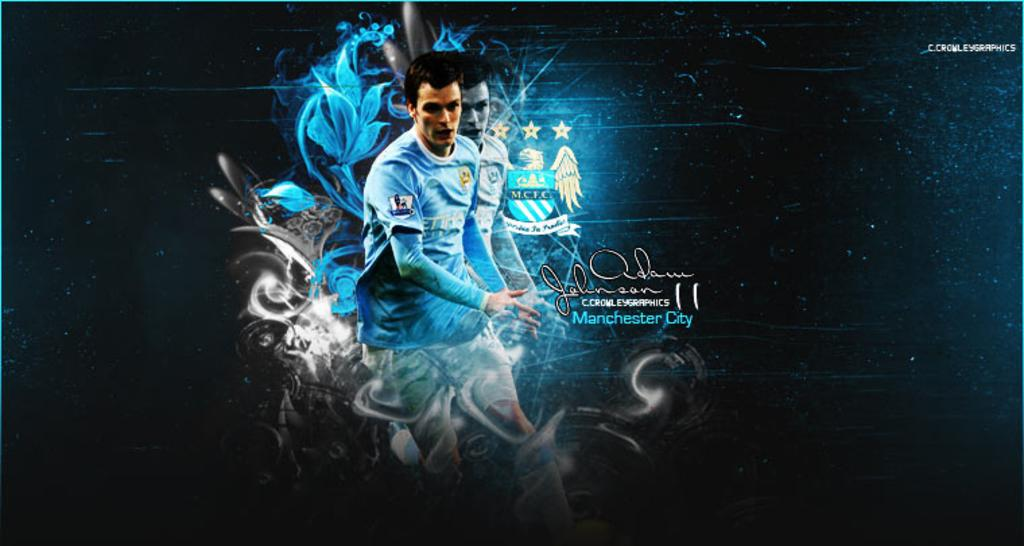<image>
Create a compact narrative representing the image presented. An athlete who plays for Manchester City is shown on an advertisement. 